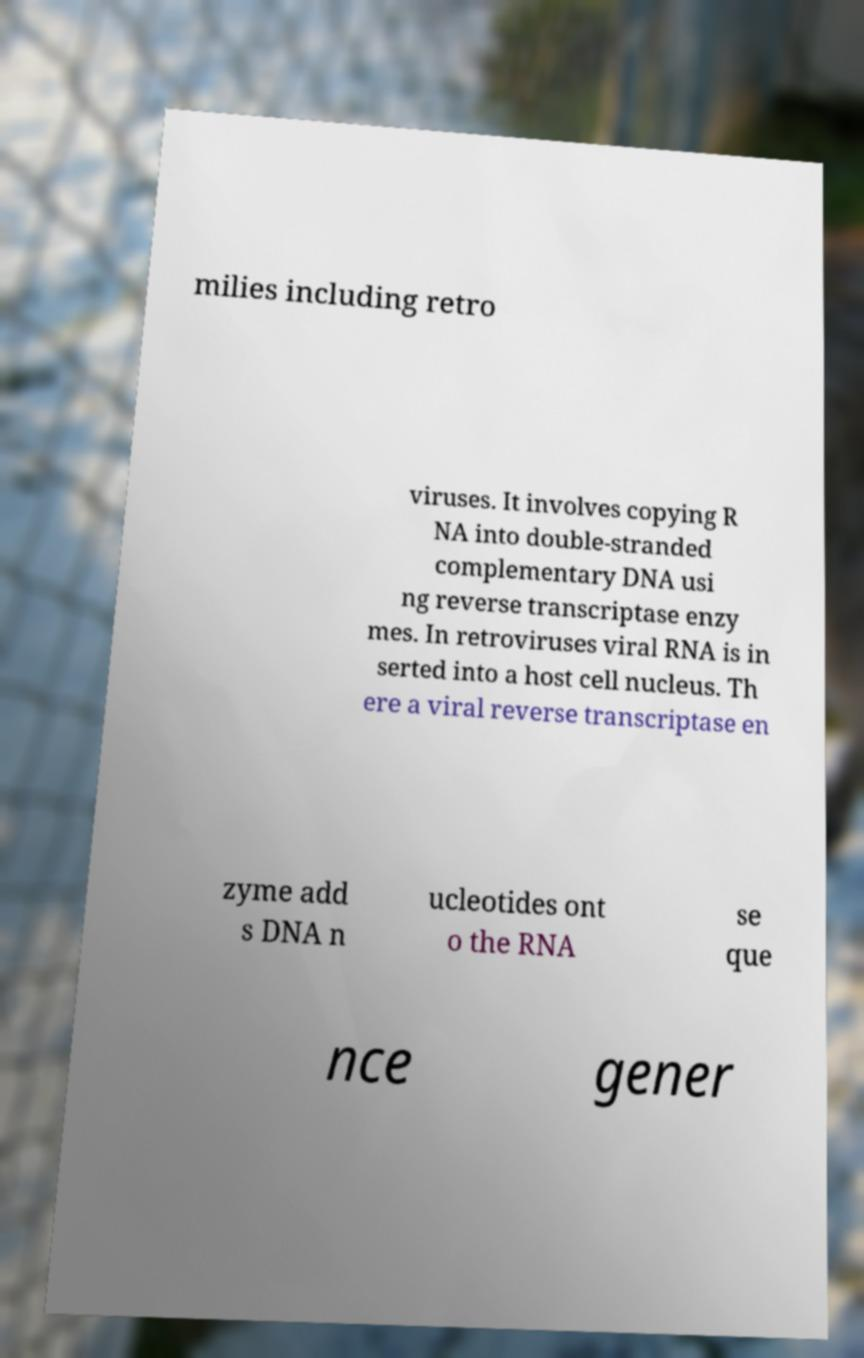Please identify and transcribe the text found in this image. milies including retro viruses. It involves copying R NA into double-stranded complementary DNA usi ng reverse transcriptase enzy mes. In retroviruses viral RNA is in serted into a host cell nucleus. Th ere a viral reverse transcriptase en zyme add s DNA n ucleotides ont o the RNA se que nce gener 